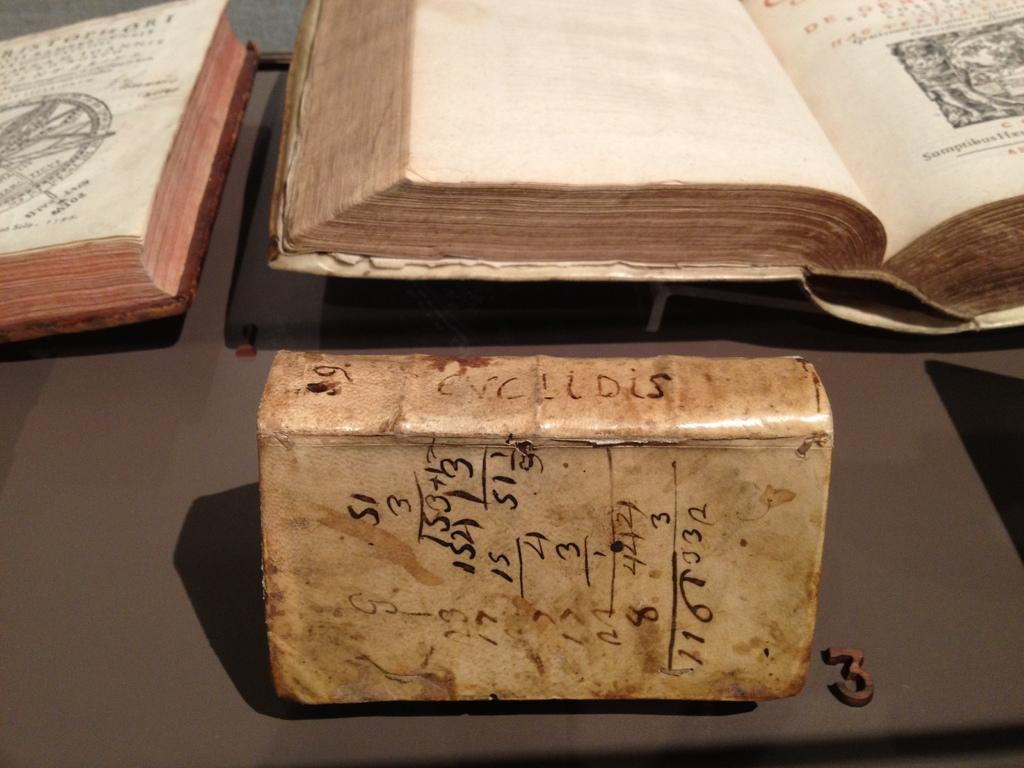<image>
Provide a brief description of the given image. Square object with numbers on it next to a small number 3. 